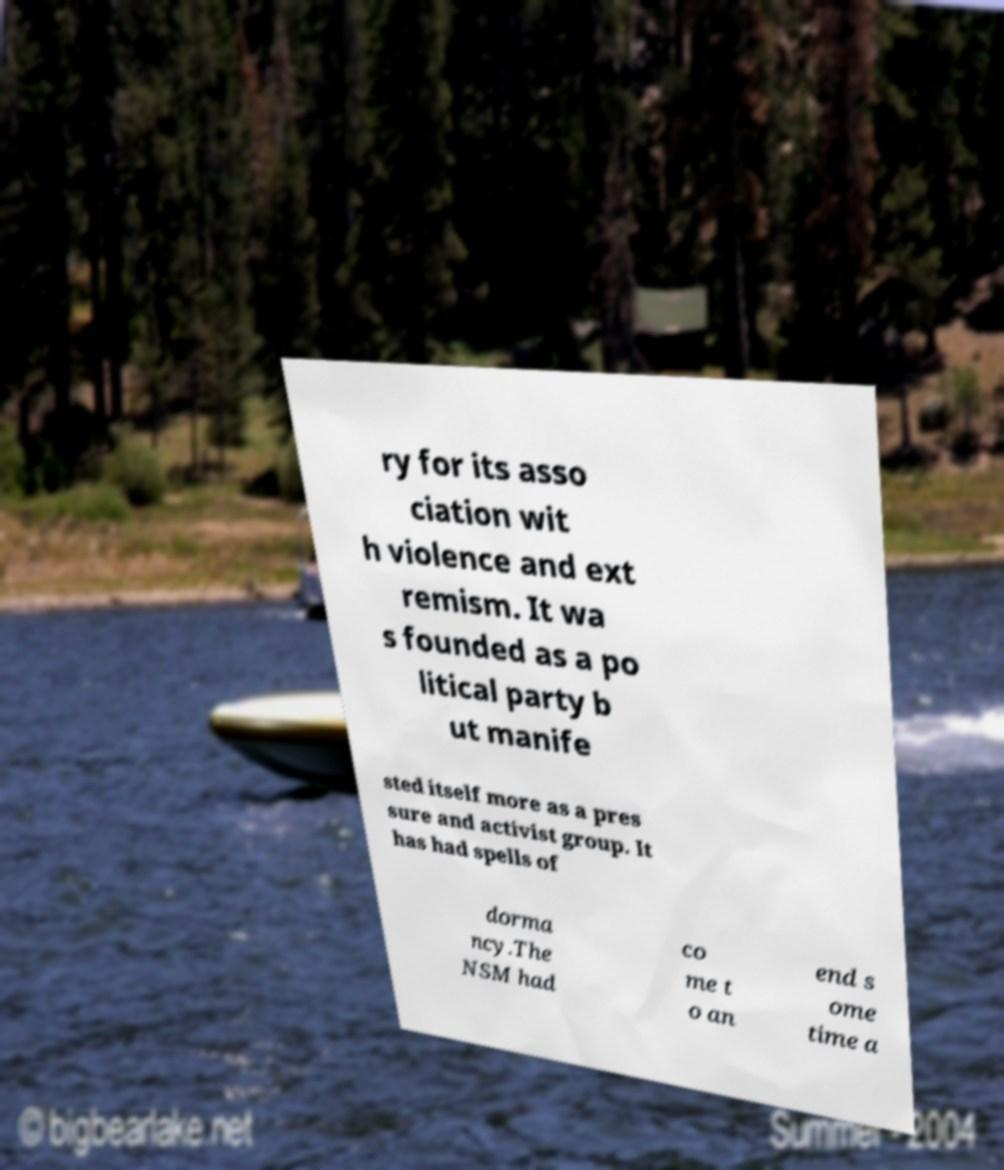Could you assist in decoding the text presented in this image and type it out clearly? ry for its asso ciation wit h violence and ext remism. It wa s founded as a po litical party b ut manife sted itself more as a pres sure and activist group. It has had spells of dorma ncy.The NSM had co me t o an end s ome time a 